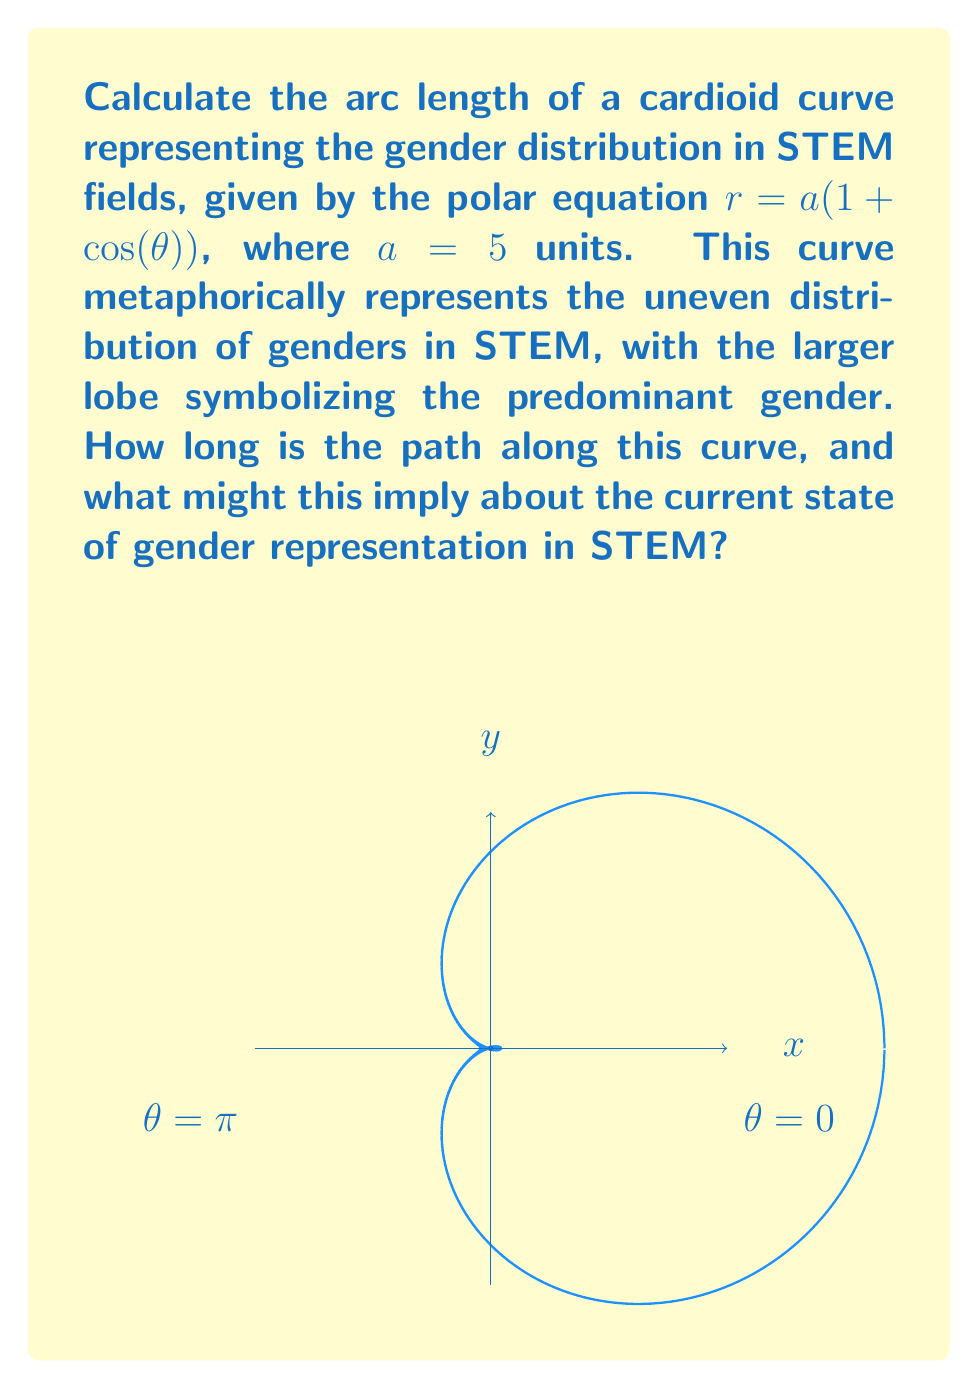What is the answer to this math problem? To calculate the arc length of the cardioid, we'll use the formula for arc length in polar coordinates:

$$L = \int_0^{2\pi} \sqrt{r^2 + \left(\frac{dr}{d\theta}\right)^2} d\theta$$

Step 1: Find $\frac{dr}{d\theta}$
$$r = a(1 + \cos(\theta))$$
$$\frac{dr}{d\theta} = -a\sin(\theta)$$

Step 2: Calculate $r^2 + \left(\frac{dr}{d\theta}\right)^2$
$$r^2 + \left(\frac{dr}{d\theta}\right)^2 = a^2(1 + \cos(\theta))^2 + a^2\sin^2(\theta)$$
$$= a^2(1 + 2\cos(\theta) + \cos^2(\theta) + \sin^2(\theta))$$
$$= a^2(2 + 2\cos(\theta))$$ (since $\cos^2(\theta) + \sin^2(\theta) = 1$)

Step 3: Simplify the integrand
$$\sqrt{r^2 + \left(\frac{dr}{d\theta}\right)^2} = a\sqrt{2 + 2\cos(\theta)} = a\sqrt{2}\sqrt{1 + \cos(\theta)}$$

Step 4: Set up the integral
$$L = a\sqrt{2} \int_0^{2\pi} \sqrt{1 + \cos(\theta)} d\theta$$

Step 5: Use the half-angle formula $\cos(\theta) = 1 - 2\sin^2(\frac{\theta}{2})$
$$L = a\sqrt{2} \int_0^{2\pi} \sqrt{2 - 2\sin^2(\frac{\theta}{2})} d\theta$$
$$= 2a\sqrt{2} \int_0^{2\pi} \cos(\frac{\theta}{2}) d\theta$$

Step 6: Evaluate the integral
$$L = 2a\sqrt{2} [2\sin(\frac{\theta}{2})]_0^{2\pi} = 8a\sqrt{2}$$

Step 7: Substitute $a = 5$
$$L = 8 \cdot 5 \cdot \sqrt{2} = 40\sqrt{2} \approx 56.57 \text{ units}$$

This result implies that the path along the gender distribution curve is quite long, suggesting a significant disparity in gender representation in STEM fields.
Answer: $40\sqrt{2}$ units 